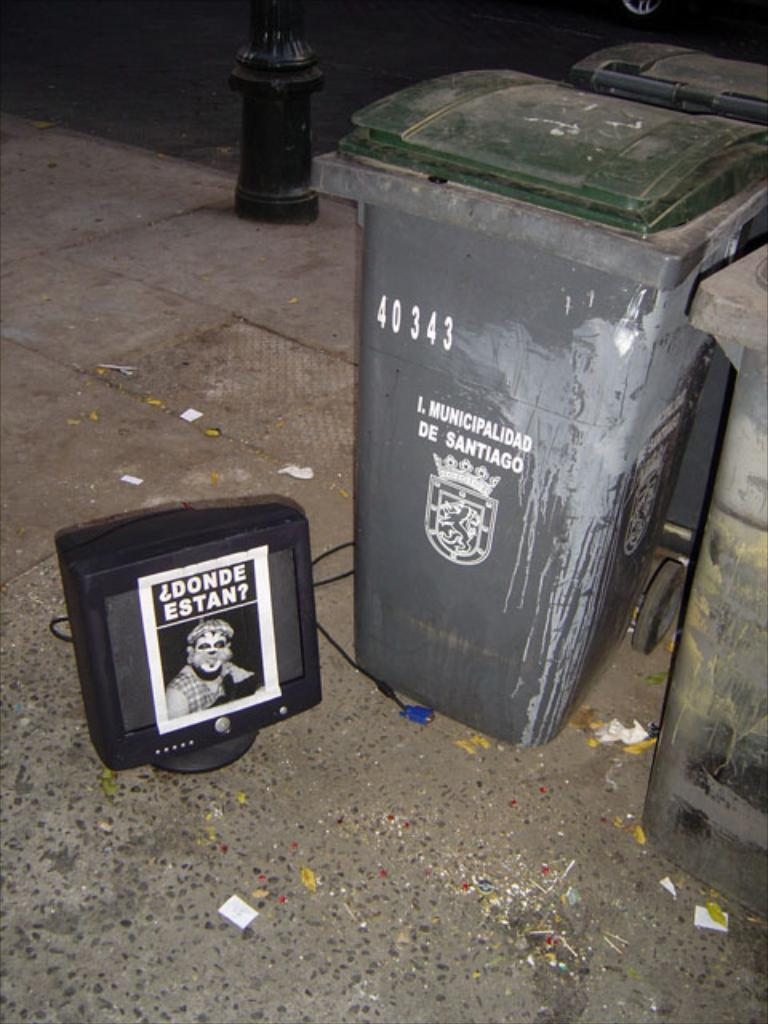<image>
Write a terse but informative summary of the picture. Black garbage can with the numbers 40343 on it. 